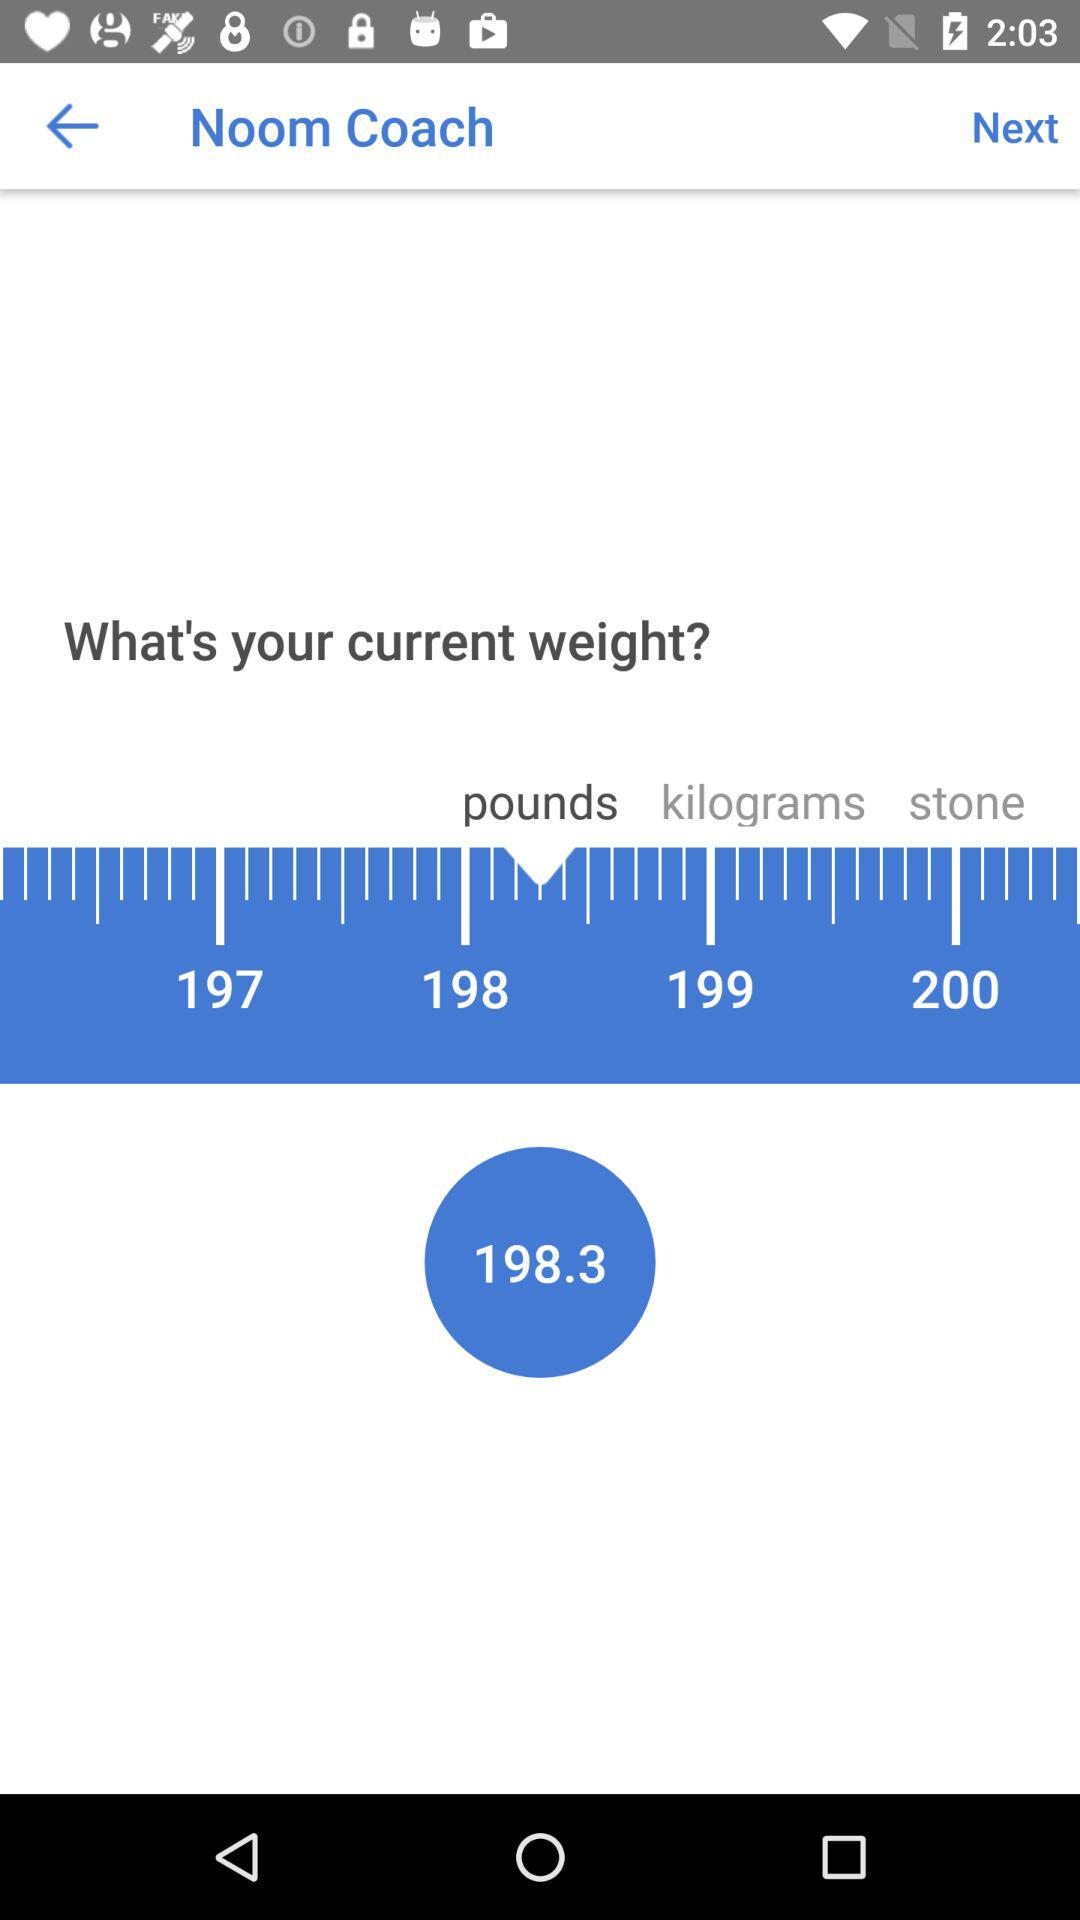What is the current weight? The current weight is 198.3 pounds. 